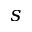<formula> <loc_0><loc_0><loc_500><loc_500>s</formula> 